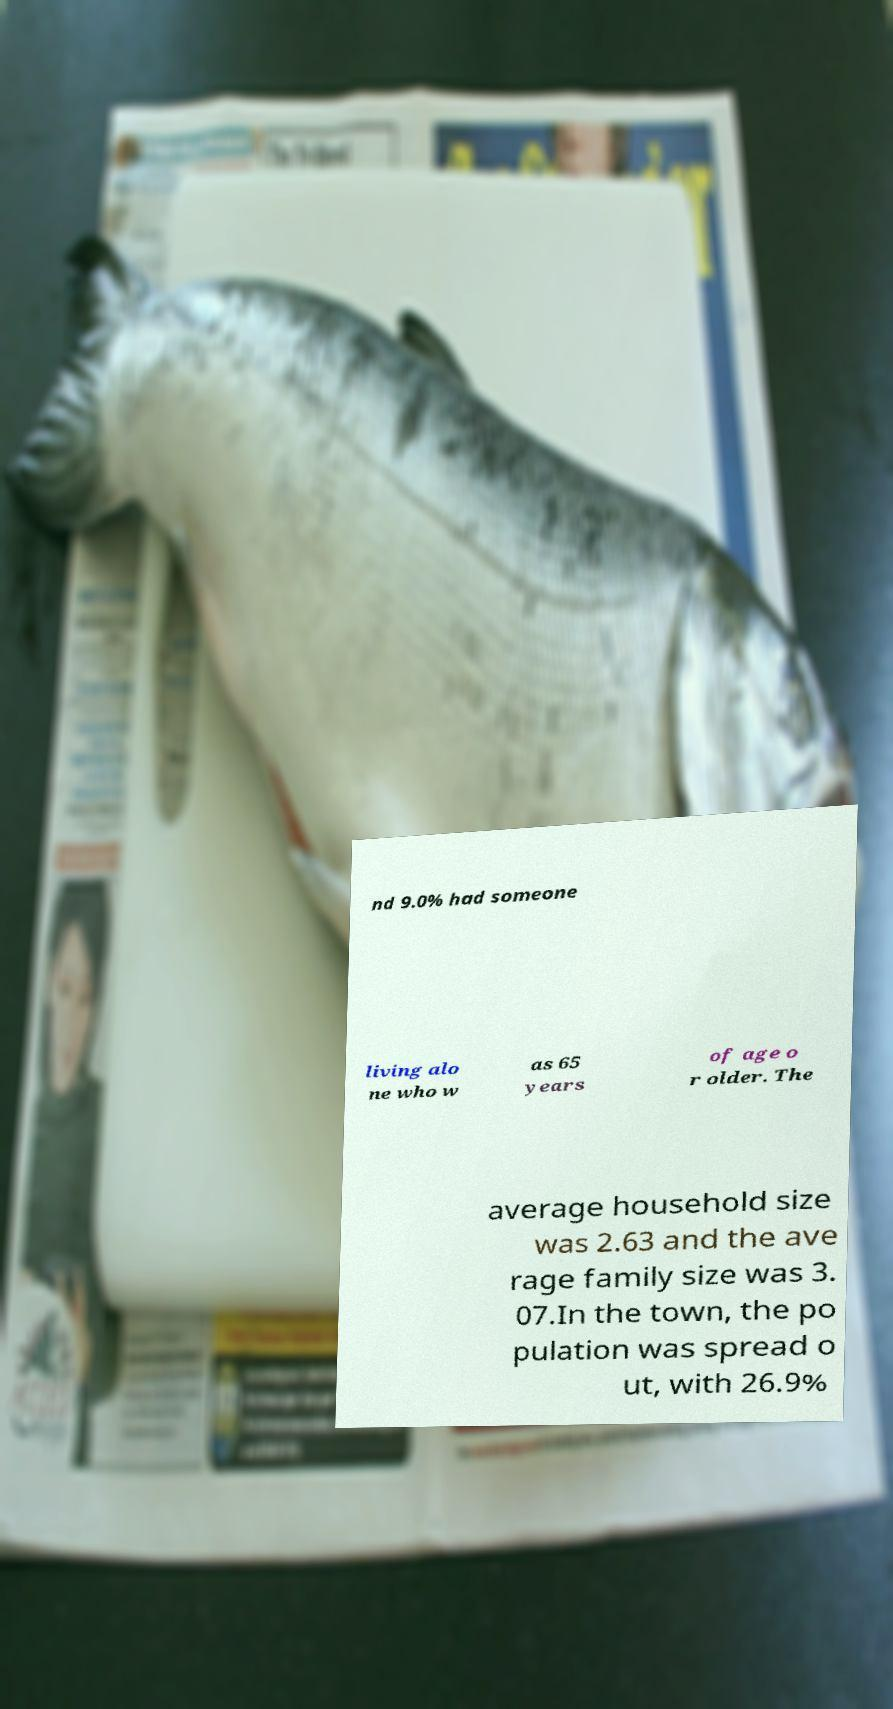I need the written content from this picture converted into text. Can you do that? nd 9.0% had someone living alo ne who w as 65 years of age o r older. The average household size was 2.63 and the ave rage family size was 3. 07.In the town, the po pulation was spread o ut, with 26.9% 